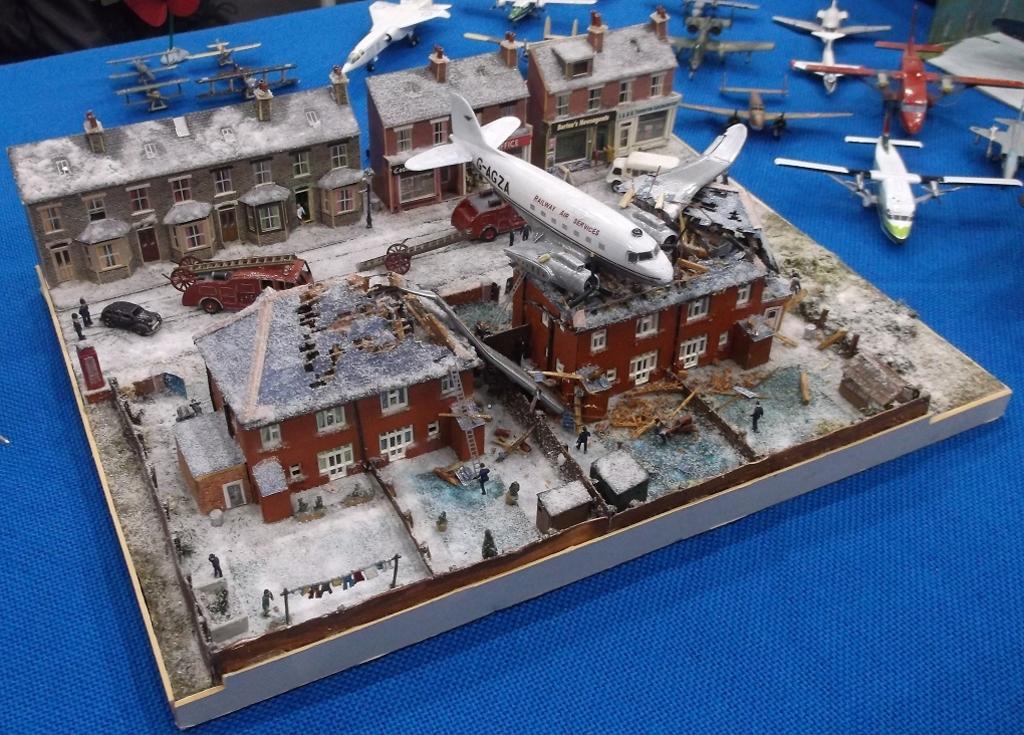How would you summarize this image in a sentence or two? This image consists of a toy house. It looks like a miniature. On the right, we can see many planes on the table. At the bottom, there is a cloth in blue color. 